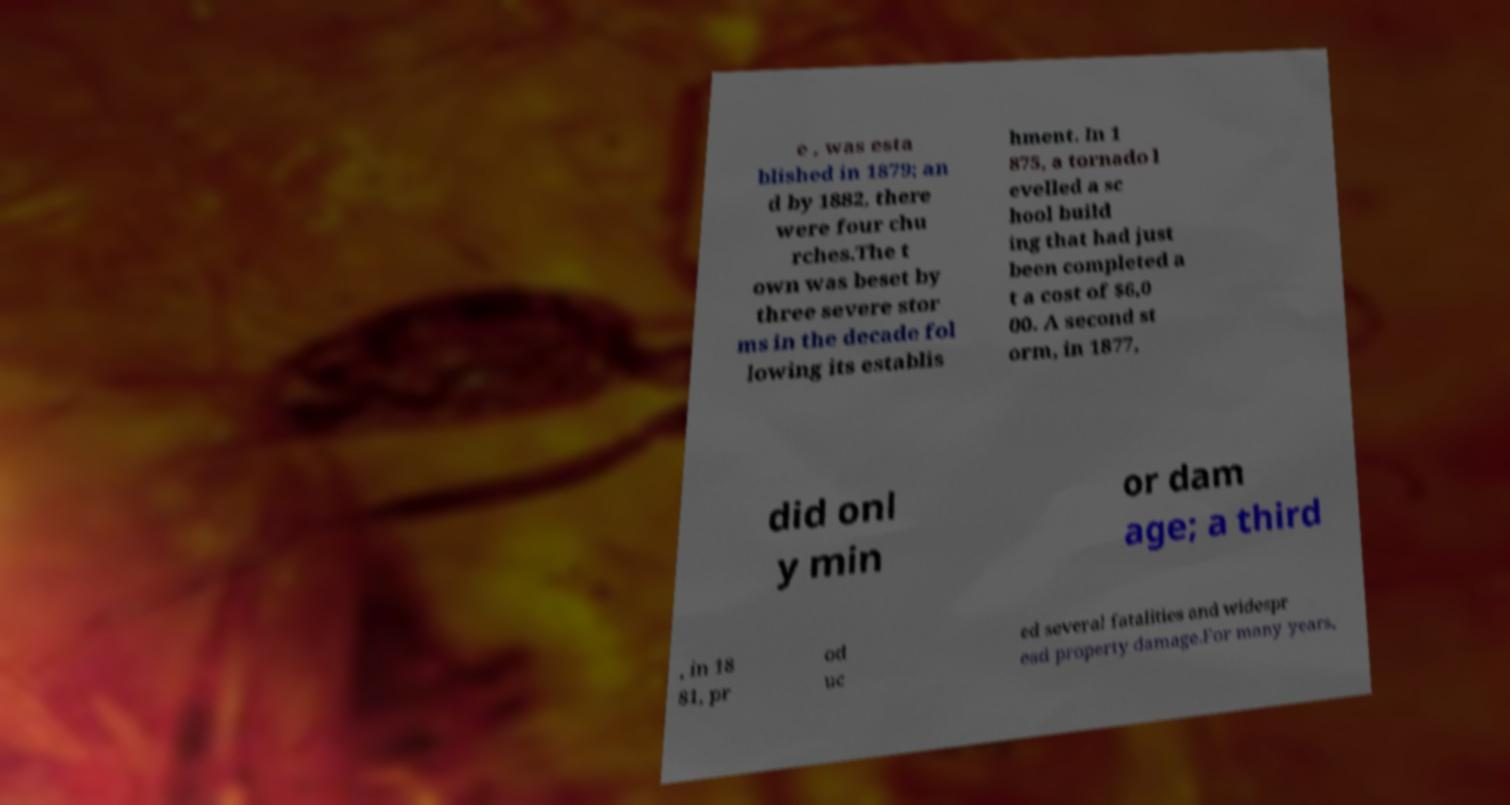Please identify and transcribe the text found in this image. e , was esta blished in 1879; an d by 1882, there were four chu rches.The t own was beset by three severe stor ms in the decade fol lowing its establis hment. In 1 875, a tornado l evelled a sc hool build ing that had just been completed a t a cost of $6,0 00. A second st orm, in 1877, did onl y min or dam age; a third , in 18 81, pr od uc ed several fatalities and widespr ead property damage.For many years, 